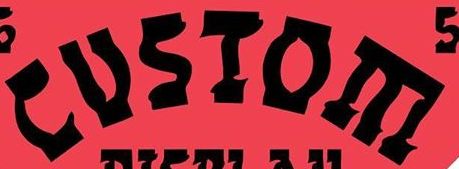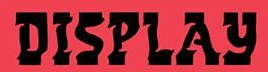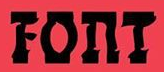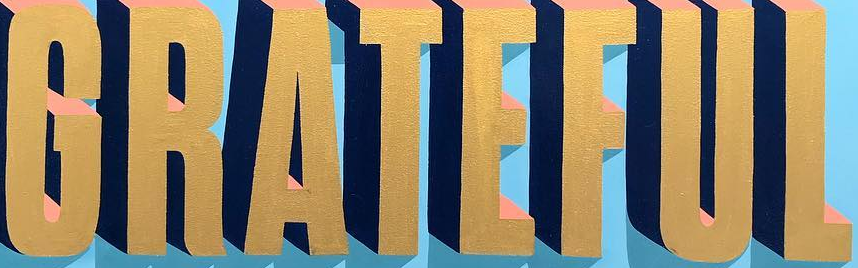What words are shown in these images in order, separated by a semicolon? CUSIOE; DISPLAY; FOnT; GRATEFUL 